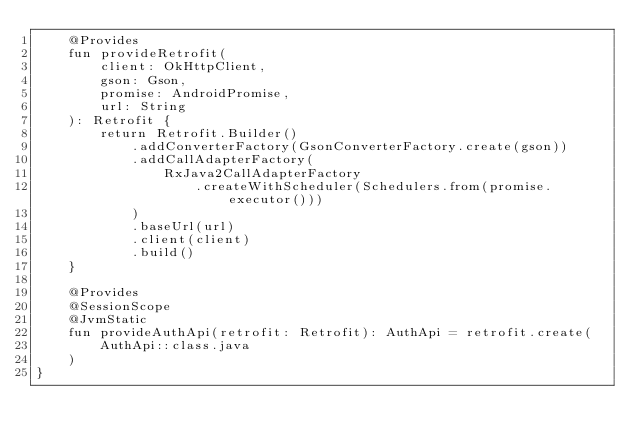<code> <loc_0><loc_0><loc_500><loc_500><_Kotlin_>    @Provides
    fun provideRetrofit(
        client: OkHttpClient,
        gson: Gson,
        promise: AndroidPromise,
        url: String
    ): Retrofit {
        return Retrofit.Builder()
            .addConverterFactory(GsonConverterFactory.create(gson))
            .addCallAdapterFactory(
                RxJava2CallAdapterFactory
                    .createWithScheduler(Schedulers.from(promise.executor()))
            )
            .baseUrl(url)
            .client(client)
            .build()
    }

    @Provides
    @SessionScope
    @JvmStatic
    fun provideAuthApi(retrofit: Retrofit): AuthApi = retrofit.create(
        AuthApi::class.java
    )
}</code> 